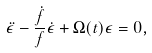Convert formula to latex. <formula><loc_0><loc_0><loc_500><loc_500>\ddot { \epsilon } - \frac { \dot { f } } { f } \dot { \epsilon } + \Omega ( t ) \epsilon = 0 ,</formula> 